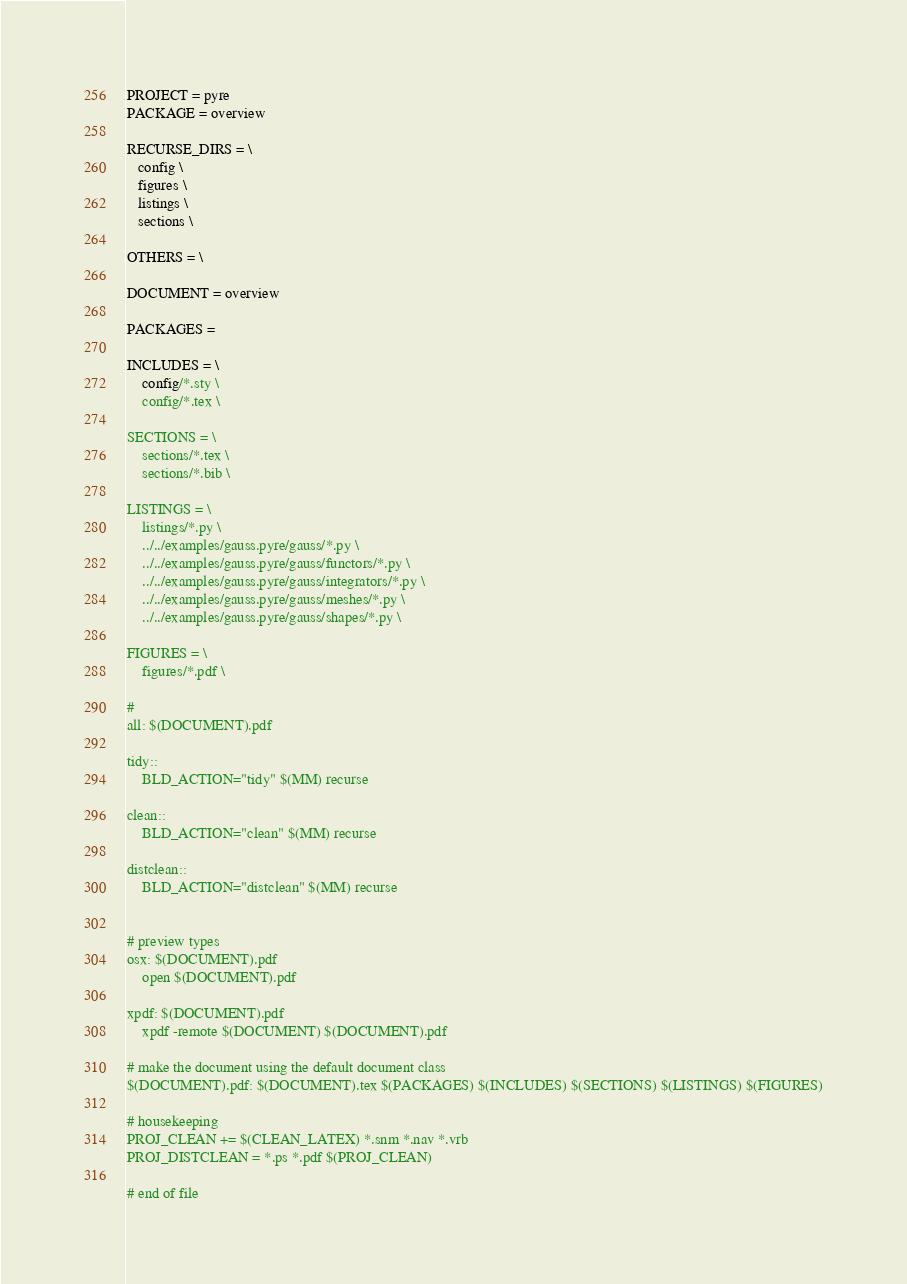Convert code to text. <code><loc_0><loc_0><loc_500><loc_500><_ObjectiveC_>
PROJECT = pyre
PACKAGE = overview

RECURSE_DIRS = \
   config \
   figures \
   listings \
   sections \

OTHERS = \

DOCUMENT = overview

PACKAGES =

INCLUDES = \
    config/*.sty \
    config/*.tex \

SECTIONS = \
    sections/*.tex \
    sections/*.bib \

LISTINGS = \
    listings/*.py \
    ../../examples/gauss.pyre/gauss/*.py \
    ../../examples/gauss.pyre/gauss/functors/*.py \
    ../../examples/gauss.pyre/gauss/integrators/*.py \
    ../../examples/gauss.pyre/gauss/meshes/*.py \
    ../../examples/gauss.pyre/gauss/shapes/*.py \

FIGURES = \
    figures/*.pdf \

#
all: $(DOCUMENT).pdf

tidy::
	BLD_ACTION="tidy" $(MM) recurse

clean::
	BLD_ACTION="clean" $(MM) recurse

distclean::
	BLD_ACTION="distclean" $(MM) recurse


# preview types
osx: $(DOCUMENT).pdf
	open $(DOCUMENT).pdf

xpdf: $(DOCUMENT).pdf
	xpdf -remote $(DOCUMENT) $(DOCUMENT).pdf

# make the document using the default document class
$(DOCUMENT).pdf: $(DOCUMENT).tex $(PACKAGES) $(INCLUDES) $(SECTIONS) $(LISTINGS) $(FIGURES)

# housekeeping
PROJ_CLEAN += $(CLEAN_LATEX) *.snm *.nav *.vrb
PROJ_DISTCLEAN = *.ps *.pdf $(PROJ_CLEAN)

# end of file
</code> 